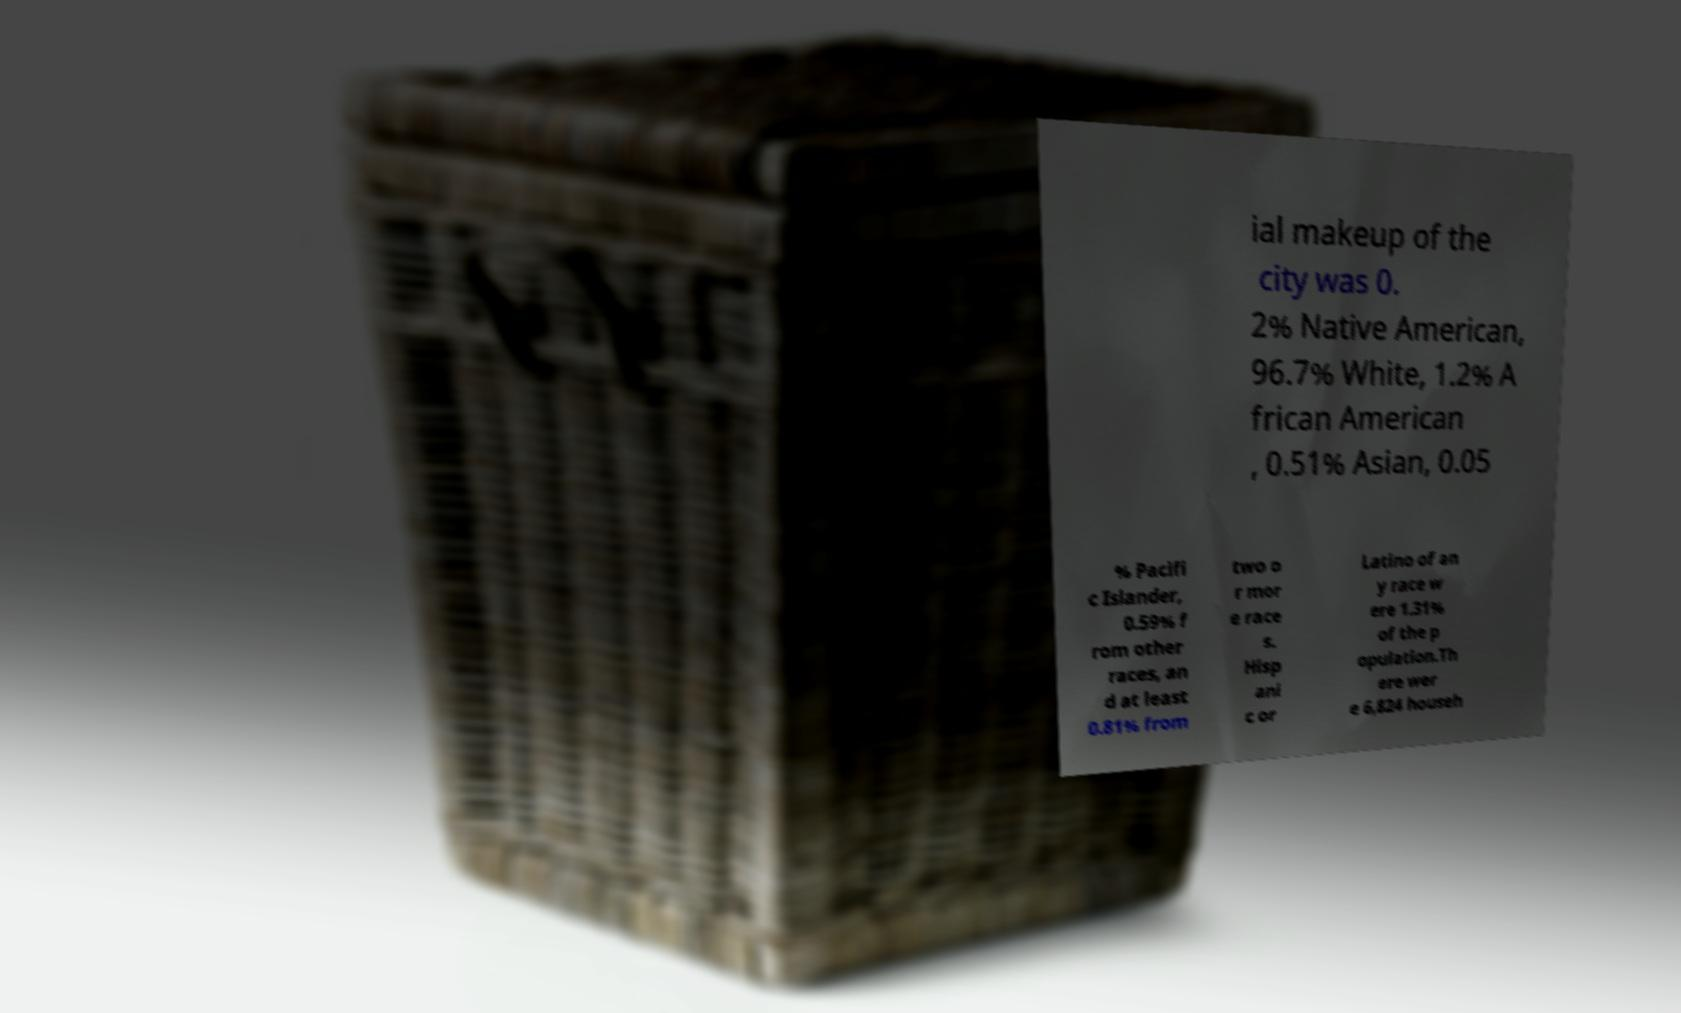Please read and relay the text visible in this image. What does it say? ial makeup of the city was 0. 2% Native American, 96.7% White, 1.2% A frican American , 0.51% Asian, 0.05 % Pacifi c Islander, 0.59% f rom other races, an d at least 0.81% from two o r mor e race s. Hisp ani c or Latino of an y race w ere 1.31% of the p opulation.Th ere wer e 6,824 househ 